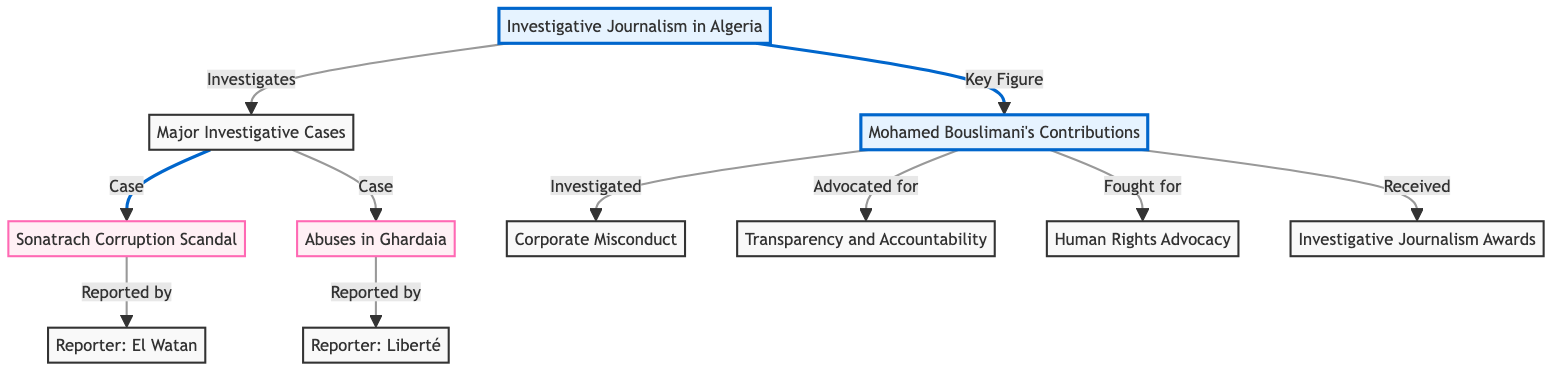What is the primary focus of the diagram? The primary focus of the diagram is on "Investigative Journalism in Algeria." This is indicated as the first node, representing the main theme of the flowchart.
Answer: Investigative Journalism in Algeria How many major cases are listed in the diagram? There are two major cases presented in the diagram: "Sonatrach Corruption Scandal" and "Abuses in Ghardaia." Each case is a separate node connected to the "Major Investigative Cases" node.
Answer: 2 Who reported the Sonatrach Corruption Scandal? The Sonatrach Corruption Scandal was reported by "El Watan," which is directly linked from the case node.
Answer: El Watan Which areas does Mohamed Bouslimani advocate for according to the diagram? The diagram specifies that Mohamed Bouslimani advocated for "Transparency and Accountability," indicating two separate nodes connected to his contributions.
Answer: Transparency and Accountability What type of contributions does Mohamed Bouslimani make in the field of human rights? Mohamed Bouslimani fights for "Human Rights Advocacy," as stated in his contributions section, showing his involvement in this area of journalism.
Answer: Human Rights Advocacy How are the major investigative cases connected to investigative journalism in Algeria? The major investigative cases are part of the broader category of investigative journalism, directly linked to the primary node. This indicates that these cases are critical aspects of the field.
Answer: By direct link What does the node "Corporate Misconduct" indicate about Bouslimani's contributions? The node "Corporate Misconduct" indicates that it is an area Bouslimani investigated, highlighting his focus on issues related to business ethics.
Answer: Investigated Which diagram style is used to denote major cases? The style indicating major cases is designated as "case," which includes a specific fill color and stroke style to differentiate them from other nodes.
Answer: Case style 